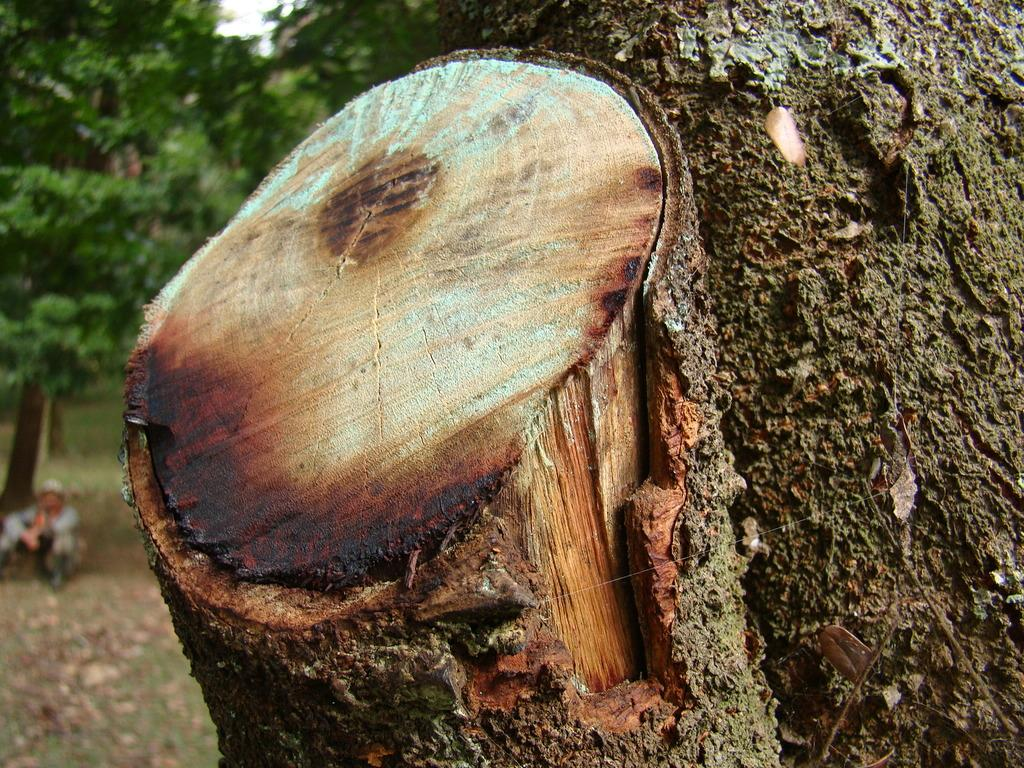What is the main subject in the foreground of the image? There is a tree trunk in the image. How would you describe the background of the image? The background of the image is blurred. Can you identify any other objects or people in the background? Yes, there is a person visible in the background of the image, and there are also trees. What time of day does the company desire to start their morning meeting in the image? There is no company or morning meeting present in the image; it features a tree trunk and a blurred background. 